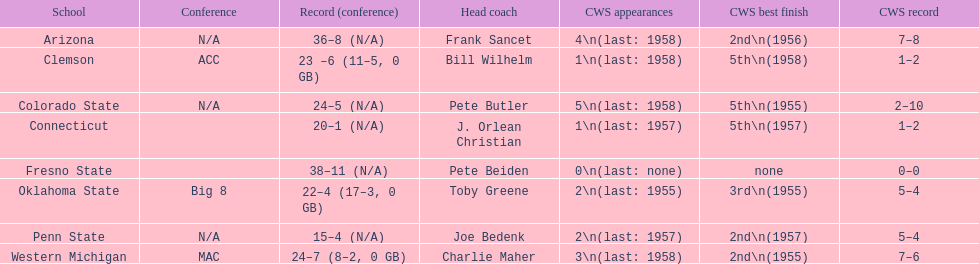Which squad did not exceed 16 victories? Penn State. 